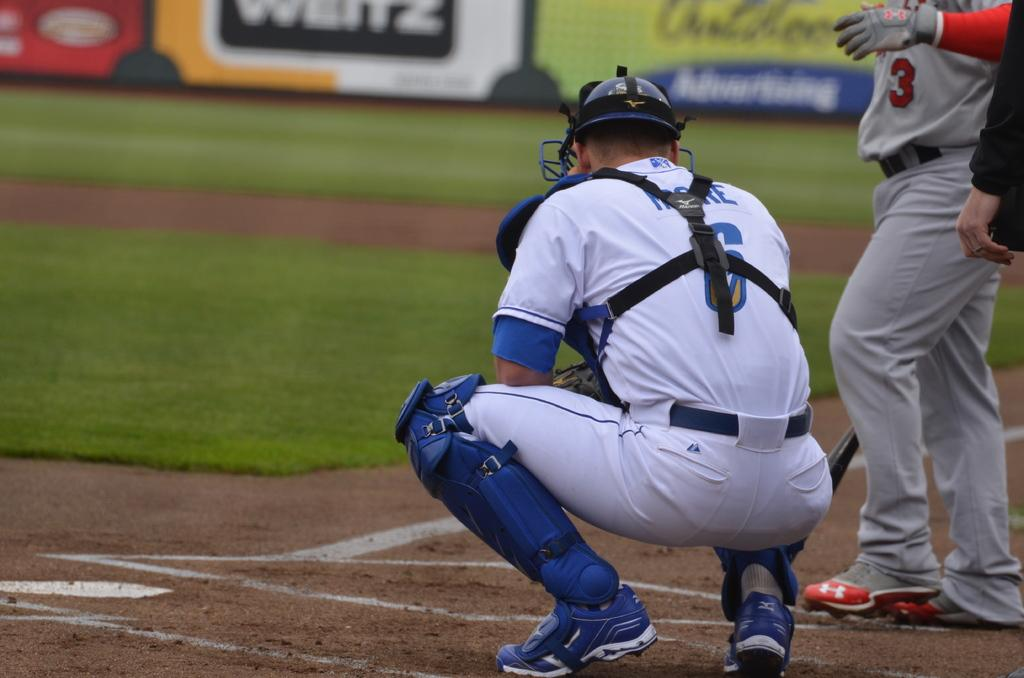What are the people in the image doing? There are players on the ground in the image, suggesting they are engaged in a sport or game. What can be seen in the background of the image? There is grass and fencing in the background of the image. What type of sound can be heard coming from the drum in the image? There is no drum present in the image, so it is not possible to determine what, if any, sound might be heard. 